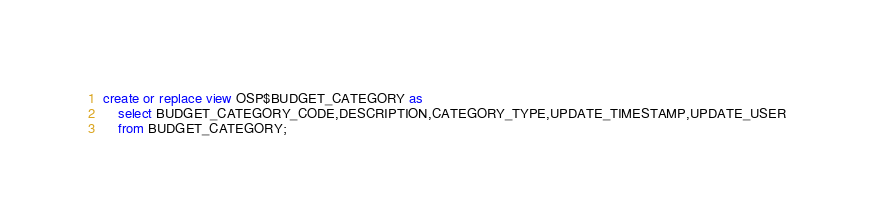Convert code to text. <code><loc_0><loc_0><loc_500><loc_500><_SQL_>create or replace view OSP$BUDGET_CATEGORY as 
	select BUDGET_CATEGORY_CODE,DESCRIPTION,CATEGORY_TYPE,UPDATE_TIMESTAMP,UPDATE_USER
	from BUDGET_CATEGORY;</code> 